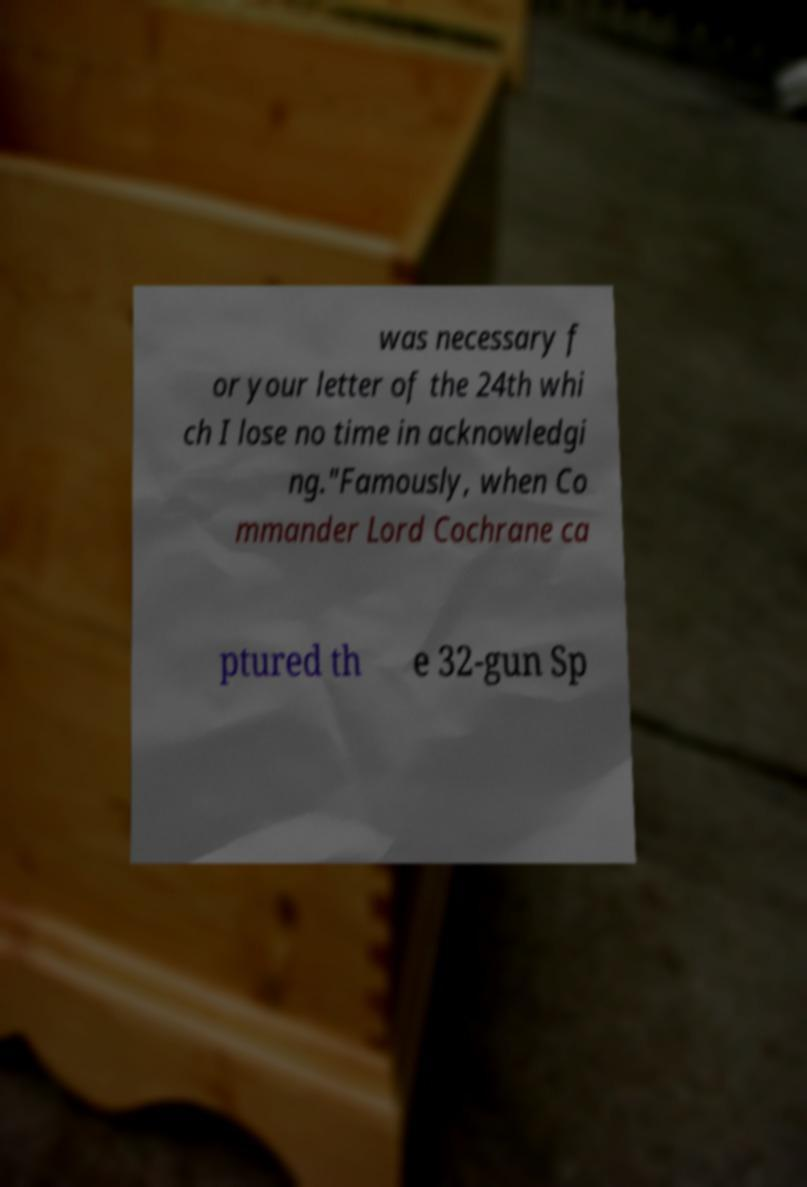I need the written content from this picture converted into text. Can you do that? was necessary f or your letter of the 24th whi ch I lose no time in acknowledgi ng."Famously, when Co mmander Lord Cochrane ca ptured th e 32-gun Sp 